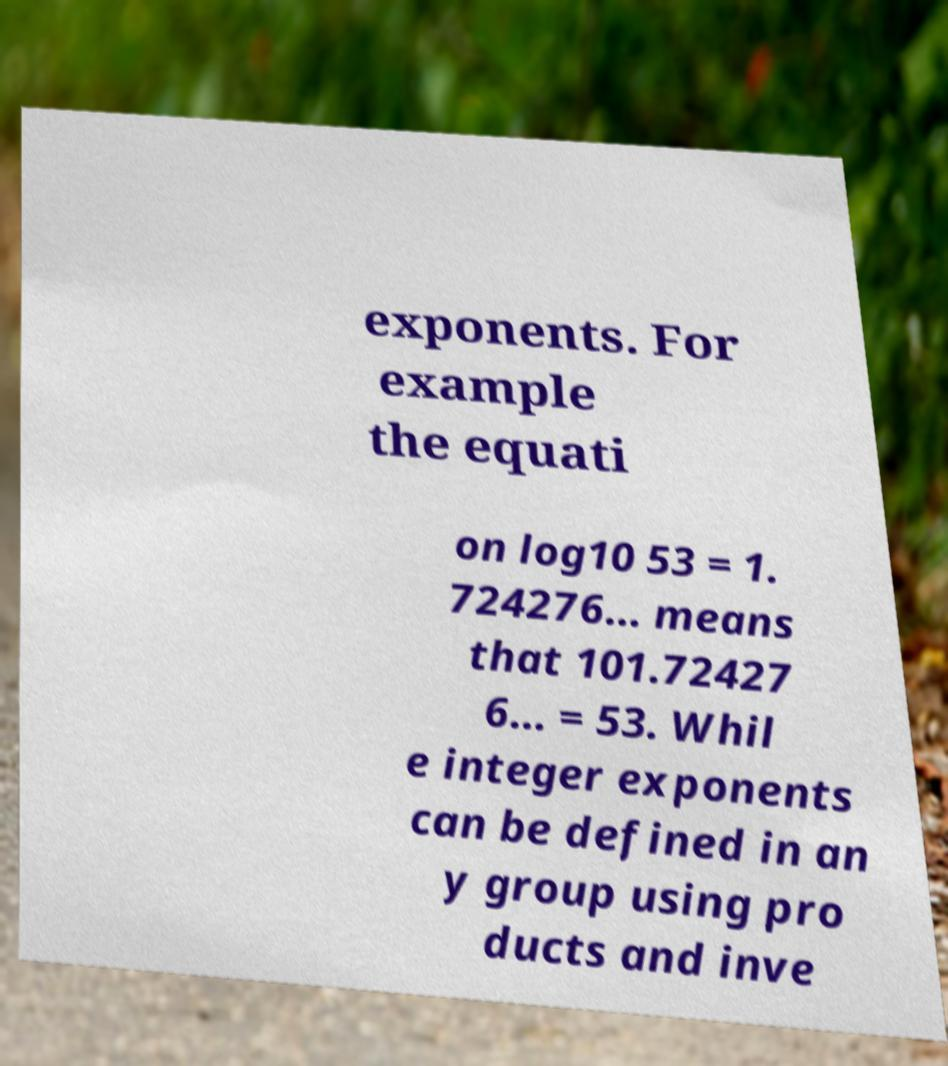There's text embedded in this image that I need extracted. Can you transcribe it verbatim? exponents. For example the equati on log10 53 = 1. 724276… means that 101.72427 6… = 53. Whil e integer exponents can be defined in an y group using pro ducts and inve 